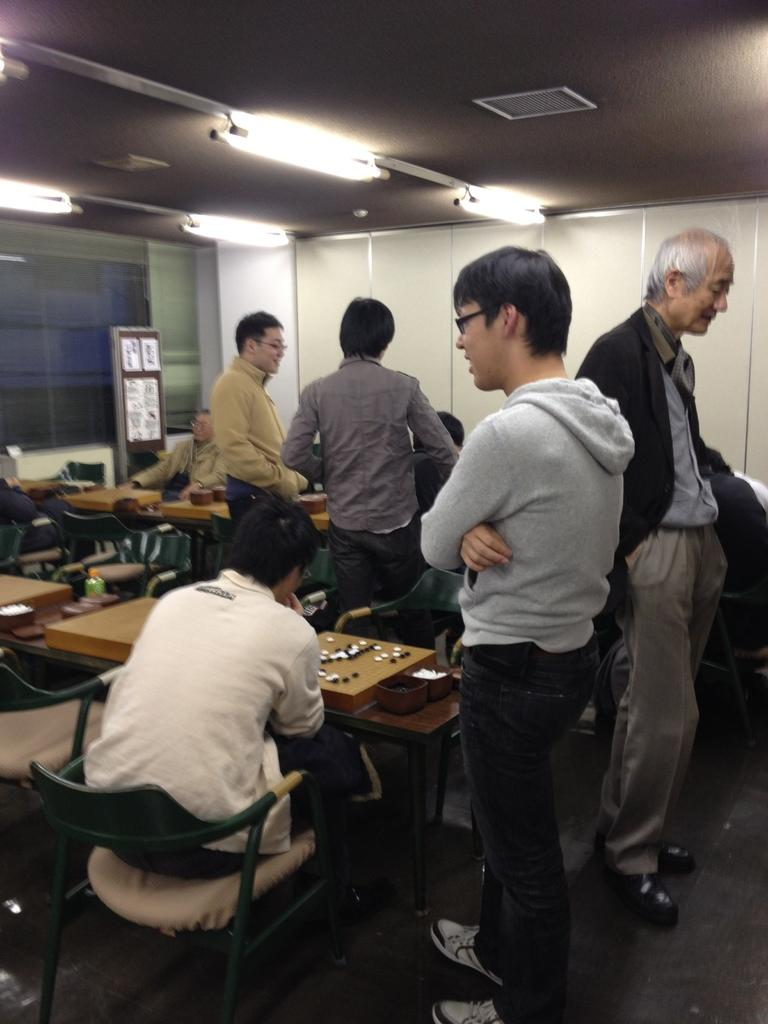What part of the room can be seen in the image? The ceiling and floor are visible in the image. What type of lighting is present in the room? Lights are present in the image. What type of furniture is in the room? Tables are in the image. What is on the board in the image? The content on the board cannot be determined from the image. How many people are in the room? People are present in the image. What positions are the people in? Some people are standing, and some are sitting on chairs. What type of discovery is being made by the dogs in the image? There are no dogs present in the image, so no discovery can be made by them. What advice does the mother give to the people in the image? There is no mother present in the image, so no advice can be given. 